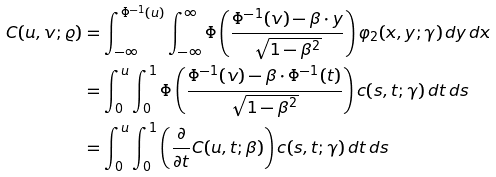Convert formula to latex. <formula><loc_0><loc_0><loc_500><loc_500>C ( u , v ; \varrho ) & = \int _ { - \infty } ^ { \Phi ^ { - 1 } ( u ) } \int _ { - \infty } ^ { \infty } \Phi \left ( \frac { \Phi ^ { - 1 } ( v ) - \beta \cdot y } { \sqrt { 1 - \beta ^ { 2 } } } \right ) \varphi _ { 2 } ( x , y ; \gamma ) \, d y \, d x \\ & = \int _ { 0 } ^ { u } \int _ { 0 } ^ { 1 } \Phi \left ( \frac { \Phi ^ { - 1 } ( v ) - \beta \cdot \Phi ^ { - 1 } ( t ) } { \sqrt { 1 - \beta ^ { 2 } } } \right ) c ( s , t ; \gamma ) \, d t \, d s \\ & = \int _ { 0 } ^ { u } \int _ { 0 } ^ { 1 } \left ( \frac { \partial } { \partial t } C ( u , t ; \beta ) \right ) c ( s , t ; \gamma ) \, d t \, d s</formula> 